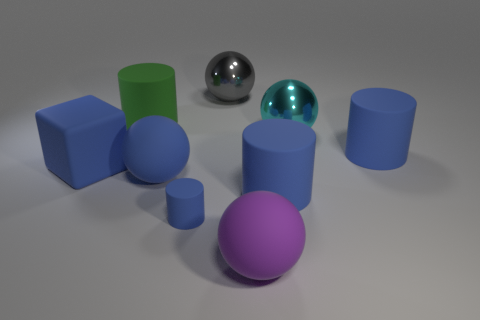Subtract all blue cylinders. How many were subtracted if there are1blue cylinders left? 2 Subtract all large cylinders. How many cylinders are left? 1 Subtract all gray spheres. How many spheres are left? 3 Subtract all yellow blocks. How many blue cylinders are left? 3 Subtract all spheres. How many objects are left? 5 Subtract 2 balls. How many balls are left? 2 Add 6 metallic objects. How many metallic objects exist? 8 Subtract 0 red balls. How many objects are left? 9 Subtract all green cubes. Subtract all cyan spheres. How many cubes are left? 1 Subtract all gray metal spheres. Subtract all large blue rubber objects. How many objects are left? 4 